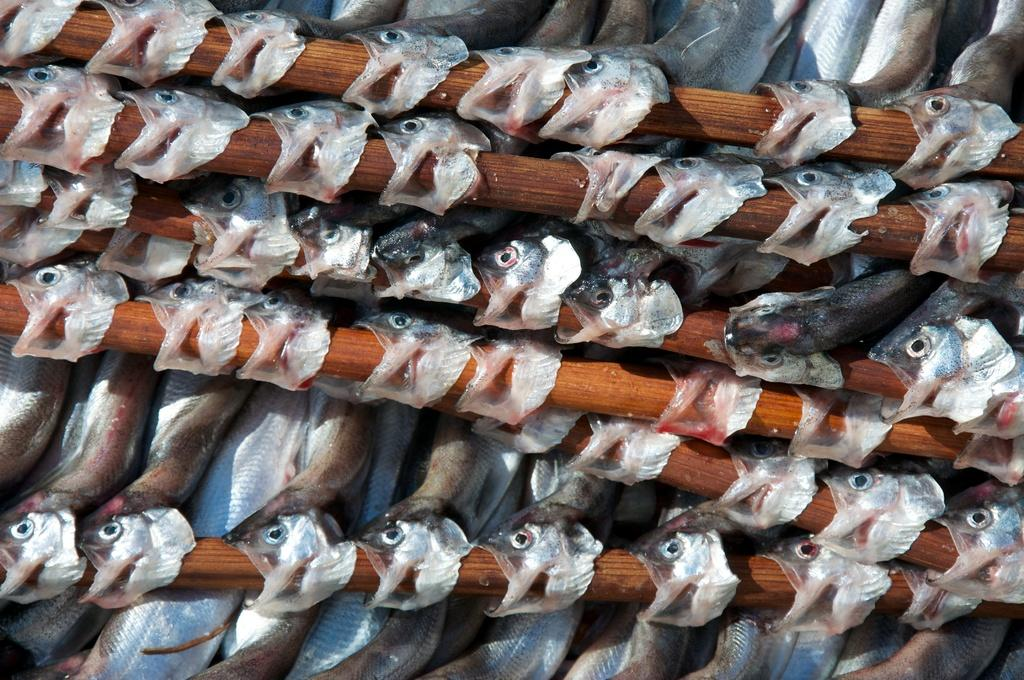What type of objects are made of wood and visible in the image? There are wooden sticks in the image. What type of living organisms can be seen in the image? There are many fish in the image. What type of art can be seen on the wooden sticks in the image? There is no art present on the wooden sticks in the image; they are plain wooden sticks. Can you describe the patch of fish in the image? There is no patch of fish in the image; the fish are spread out and not grouped together in a patch. 